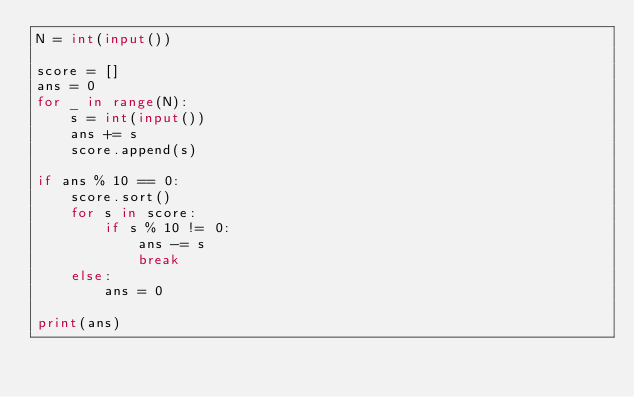Convert code to text. <code><loc_0><loc_0><loc_500><loc_500><_Python_>N = int(input())

score = []
ans = 0
for _ in range(N):
    s = int(input())
    ans += s
    score.append(s)

if ans % 10 == 0:
    score.sort()
    for s in score:
        if s % 10 != 0:
            ans -= s
            break
    else:
        ans = 0

print(ans)</code> 